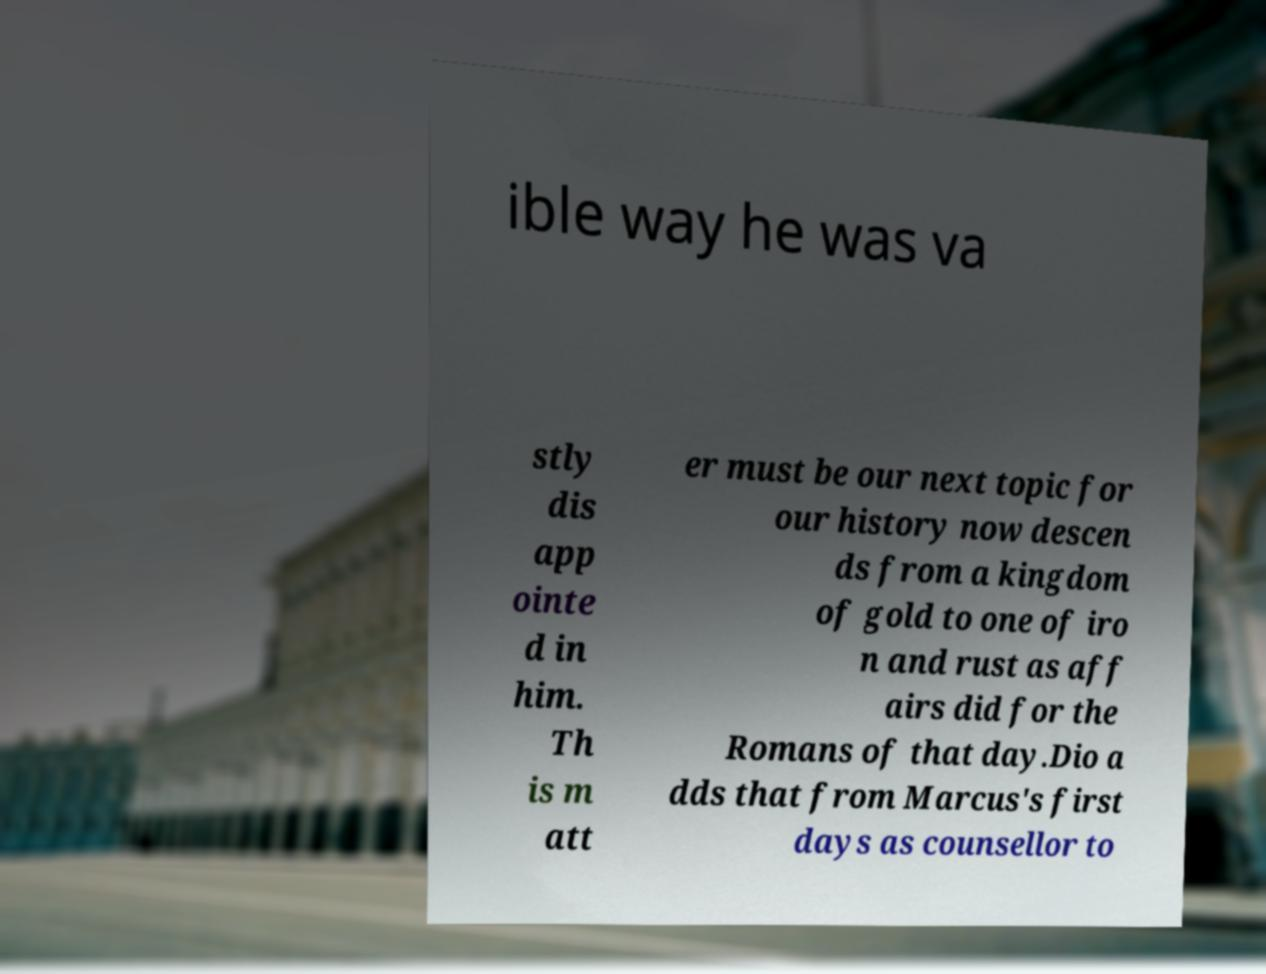Could you extract and type out the text from this image? ible way he was va stly dis app ointe d in him. Th is m att er must be our next topic for our history now descen ds from a kingdom of gold to one of iro n and rust as aff airs did for the Romans of that day.Dio a dds that from Marcus's first days as counsellor to 